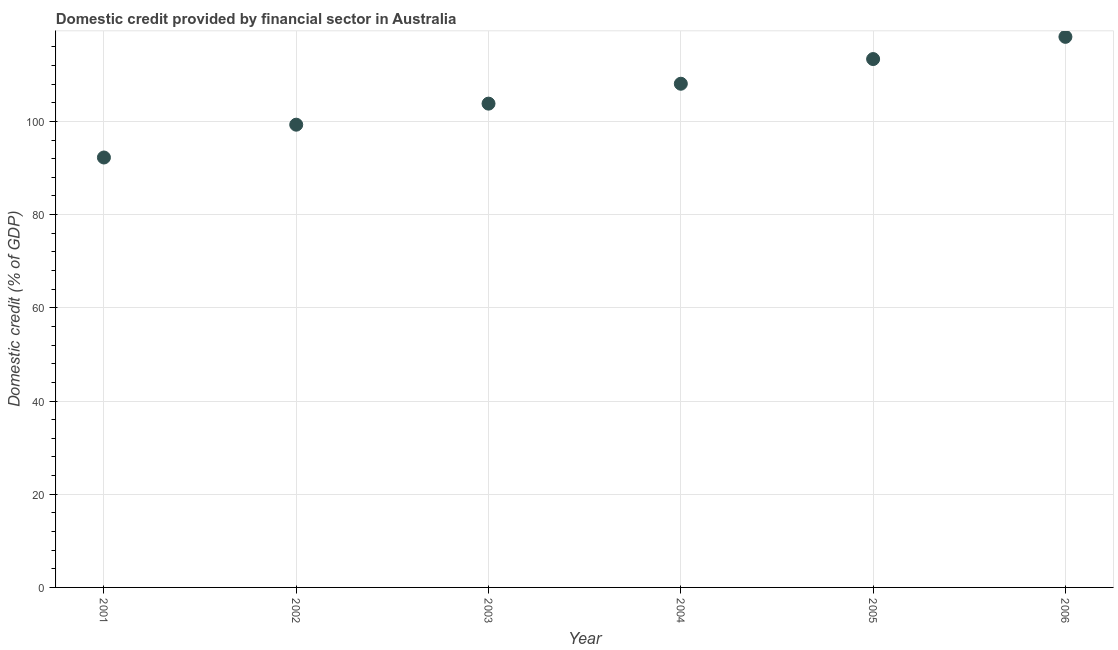What is the domestic credit provided by financial sector in 2003?
Provide a succinct answer. 103.81. Across all years, what is the maximum domestic credit provided by financial sector?
Provide a succinct answer. 118.14. Across all years, what is the minimum domestic credit provided by financial sector?
Ensure brevity in your answer.  92.25. In which year was the domestic credit provided by financial sector minimum?
Your answer should be very brief. 2001. What is the sum of the domestic credit provided by financial sector?
Give a very brief answer. 634.94. What is the difference between the domestic credit provided by financial sector in 2003 and 2006?
Keep it short and to the point. -14.33. What is the average domestic credit provided by financial sector per year?
Provide a succinct answer. 105.82. What is the median domestic credit provided by financial sector?
Provide a short and direct response. 105.94. What is the ratio of the domestic credit provided by financial sector in 2003 to that in 2006?
Offer a very short reply. 0.88. Is the domestic credit provided by financial sector in 2003 less than that in 2004?
Give a very brief answer. Yes. Is the difference between the domestic credit provided by financial sector in 2002 and 2004 greater than the difference between any two years?
Keep it short and to the point. No. What is the difference between the highest and the second highest domestic credit provided by financial sector?
Ensure brevity in your answer.  4.76. What is the difference between the highest and the lowest domestic credit provided by financial sector?
Your response must be concise. 25.89. How many dotlines are there?
Your response must be concise. 1. What is the difference between two consecutive major ticks on the Y-axis?
Keep it short and to the point. 20. Are the values on the major ticks of Y-axis written in scientific E-notation?
Give a very brief answer. No. What is the title of the graph?
Ensure brevity in your answer.  Domestic credit provided by financial sector in Australia. What is the label or title of the Y-axis?
Give a very brief answer. Domestic credit (% of GDP). What is the Domestic credit (% of GDP) in 2001?
Keep it short and to the point. 92.25. What is the Domestic credit (% of GDP) in 2002?
Your response must be concise. 99.29. What is the Domestic credit (% of GDP) in 2003?
Provide a succinct answer. 103.81. What is the Domestic credit (% of GDP) in 2004?
Provide a short and direct response. 108.08. What is the Domestic credit (% of GDP) in 2005?
Give a very brief answer. 113.37. What is the Domestic credit (% of GDP) in 2006?
Keep it short and to the point. 118.14. What is the difference between the Domestic credit (% of GDP) in 2001 and 2002?
Ensure brevity in your answer.  -7.04. What is the difference between the Domestic credit (% of GDP) in 2001 and 2003?
Give a very brief answer. -11.56. What is the difference between the Domestic credit (% of GDP) in 2001 and 2004?
Provide a succinct answer. -15.83. What is the difference between the Domestic credit (% of GDP) in 2001 and 2005?
Make the answer very short. -21.12. What is the difference between the Domestic credit (% of GDP) in 2001 and 2006?
Your answer should be very brief. -25.89. What is the difference between the Domestic credit (% of GDP) in 2002 and 2003?
Your answer should be compact. -4.52. What is the difference between the Domestic credit (% of GDP) in 2002 and 2004?
Provide a succinct answer. -8.79. What is the difference between the Domestic credit (% of GDP) in 2002 and 2005?
Provide a short and direct response. -14.08. What is the difference between the Domestic credit (% of GDP) in 2002 and 2006?
Provide a short and direct response. -18.85. What is the difference between the Domestic credit (% of GDP) in 2003 and 2004?
Make the answer very short. -4.27. What is the difference between the Domestic credit (% of GDP) in 2003 and 2005?
Offer a very short reply. -9.56. What is the difference between the Domestic credit (% of GDP) in 2003 and 2006?
Provide a short and direct response. -14.33. What is the difference between the Domestic credit (% of GDP) in 2004 and 2005?
Give a very brief answer. -5.3. What is the difference between the Domestic credit (% of GDP) in 2004 and 2006?
Provide a succinct answer. -10.06. What is the difference between the Domestic credit (% of GDP) in 2005 and 2006?
Offer a terse response. -4.76. What is the ratio of the Domestic credit (% of GDP) in 2001 to that in 2002?
Keep it short and to the point. 0.93. What is the ratio of the Domestic credit (% of GDP) in 2001 to that in 2003?
Ensure brevity in your answer.  0.89. What is the ratio of the Domestic credit (% of GDP) in 2001 to that in 2004?
Provide a succinct answer. 0.85. What is the ratio of the Domestic credit (% of GDP) in 2001 to that in 2005?
Your response must be concise. 0.81. What is the ratio of the Domestic credit (% of GDP) in 2001 to that in 2006?
Keep it short and to the point. 0.78. What is the ratio of the Domestic credit (% of GDP) in 2002 to that in 2003?
Your answer should be very brief. 0.96. What is the ratio of the Domestic credit (% of GDP) in 2002 to that in 2004?
Your answer should be compact. 0.92. What is the ratio of the Domestic credit (% of GDP) in 2002 to that in 2005?
Offer a very short reply. 0.88. What is the ratio of the Domestic credit (% of GDP) in 2002 to that in 2006?
Your response must be concise. 0.84. What is the ratio of the Domestic credit (% of GDP) in 2003 to that in 2004?
Your response must be concise. 0.96. What is the ratio of the Domestic credit (% of GDP) in 2003 to that in 2005?
Keep it short and to the point. 0.92. What is the ratio of the Domestic credit (% of GDP) in 2003 to that in 2006?
Give a very brief answer. 0.88. What is the ratio of the Domestic credit (% of GDP) in 2004 to that in 2005?
Make the answer very short. 0.95. What is the ratio of the Domestic credit (% of GDP) in 2004 to that in 2006?
Offer a very short reply. 0.92. 